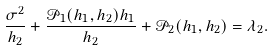Convert formula to latex. <formula><loc_0><loc_0><loc_500><loc_500>\frac { \sigma ^ { 2 } } { h _ { 2 } } + \frac { \mathcal { P } _ { 1 } ( h _ { 1 } , h _ { 2 } ) h _ { 1 } } { h _ { 2 } } + \mathcal { P } _ { 2 } ( h _ { 1 } , h _ { 2 } ) = \lambda _ { 2 } .</formula> 